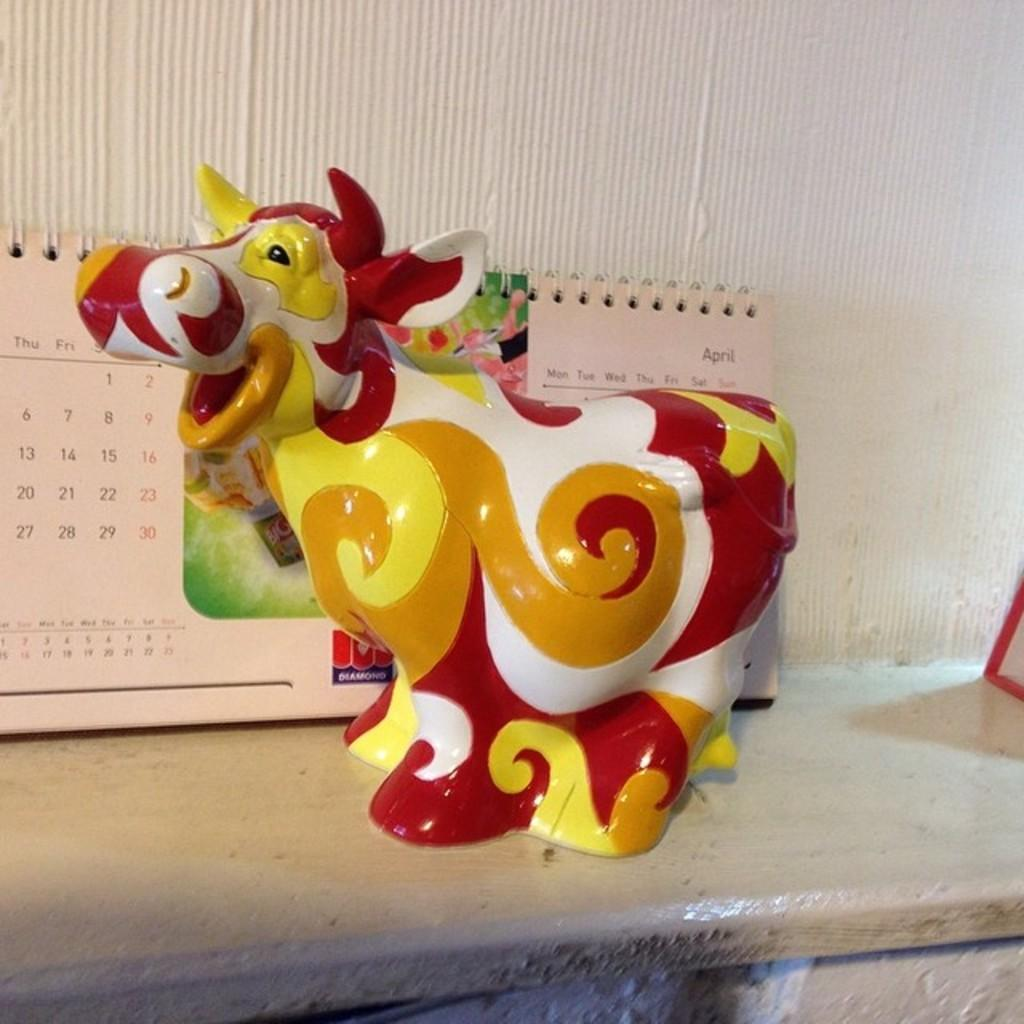What object is placed on the table in the image? There is a toy on the table. What other item can be seen on the table? There is a calendar on the table. What is visible in the background of the image? There is a wall in the background of the image. How many holes are visible in the toy in the image? There is no information about holes in the toy, as the facts provided do not mention any details about the toy's features. 